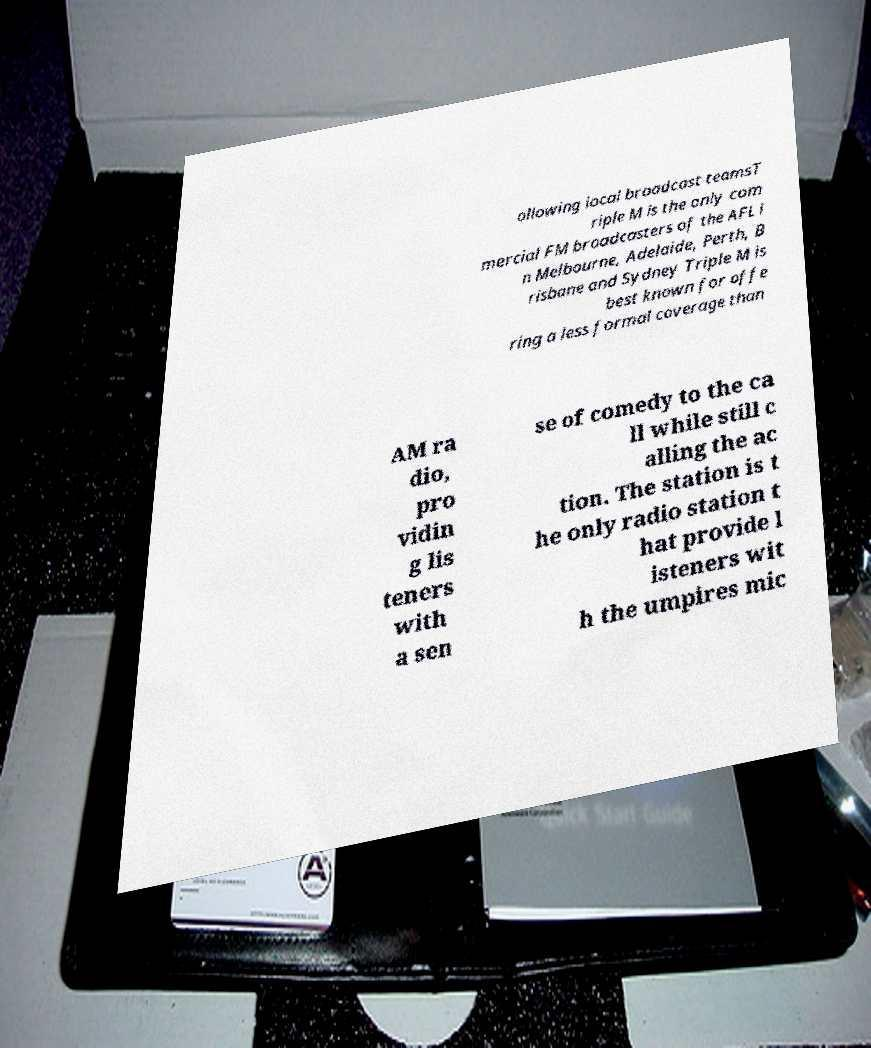What messages or text are displayed in this image? I need them in a readable, typed format. ollowing local broadcast teamsT riple M is the only com mercial FM broadcasters of the AFL i n Melbourne, Adelaide, Perth, B risbane and Sydney Triple M is best known for offe ring a less formal coverage than AM ra dio, pro vidin g lis teners with a sen se of comedy to the ca ll while still c alling the ac tion. The station is t he only radio station t hat provide l isteners wit h the umpires mic 